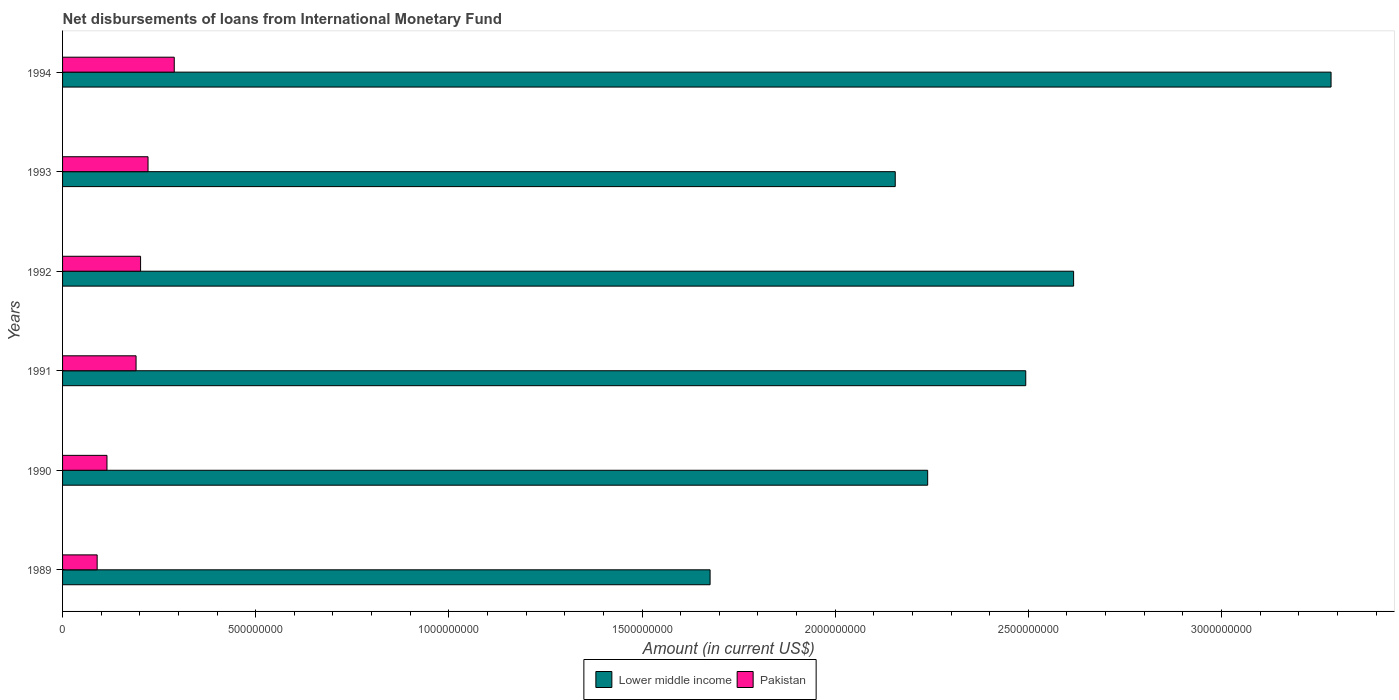What is the label of the 3rd group of bars from the top?
Your answer should be compact. 1992. In how many cases, is the number of bars for a given year not equal to the number of legend labels?
Offer a very short reply. 0. What is the amount of loans disbursed in Lower middle income in 1990?
Your answer should be very brief. 2.24e+09. Across all years, what is the maximum amount of loans disbursed in Lower middle income?
Provide a succinct answer. 3.28e+09. Across all years, what is the minimum amount of loans disbursed in Pakistan?
Offer a terse response. 8.95e+07. In which year was the amount of loans disbursed in Pakistan maximum?
Your answer should be very brief. 1994. In which year was the amount of loans disbursed in Pakistan minimum?
Your response must be concise. 1989. What is the total amount of loans disbursed in Pakistan in the graph?
Your response must be concise. 1.11e+09. What is the difference between the amount of loans disbursed in Pakistan in 1992 and that in 1993?
Keep it short and to the point. -1.93e+07. What is the difference between the amount of loans disbursed in Pakistan in 1990 and the amount of loans disbursed in Lower middle income in 1991?
Make the answer very short. -2.38e+09. What is the average amount of loans disbursed in Lower middle income per year?
Your response must be concise. 2.41e+09. In the year 1993, what is the difference between the amount of loans disbursed in Lower middle income and amount of loans disbursed in Pakistan?
Provide a succinct answer. 1.93e+09. In how many years, is the amount of loans disbursed in Pakistan greater than 2600000000 US$?
Provide a succinct answer. 0. What is the ratio of the amount of loans disbursed in Pakistan in 1990 to that in 1992?
Your answer should be very brief. 0.57. What is the difference between the highest and the second highest amount of loans disbursed in Pakistan?
Provide a succinct answer. 6.79e+07. What is the difference between the highest and the lowest amount of loans disbursed in Lower middle income?
Offer a very short reply. 1.61e+09. Is the sum of the amount of loans disbursed in Lower middle income in 1989 and 1994 greater than the maximum amount of loans disbursed in Pakistan across all years?
Ensure brevity in your answer.  Yes. What does the 2nd bar from the top in 1994 represents?
Ensure brevity in your answer.  Lower middle income. What does the 2nd bar from the bottom in 1993 represents?
Offer a terse response. Pakistan. How many bars are there?
Offer a terse response. 12. What is the difference between two consecutive major ticks on the X-axis?
Your answer should be very brief. 5.00e+08. Are the values on the major ticks of X-axis written in scientific E-notation?
Ensure brevity in your answer.  No. Does the graph contain grids?
Ensure brevity in your answer.  No. Where does the legend appear in the graph?
Your response must be concise. Bottom center. How many legend labels are there?
Make the answer very short. 2. How are the legend labels stacked?
Your answer should be very brief. Horizontal. What is the title of the graph?
Give a very brief answer. Net disbursements of loans from International Monetary Fund. What is the label or title of the X-axis?
Your answer should be very brief. Amount (in current US$). What is the label or title of the Y-axis?
Provide a short and direct response. Years. What is the Amount (in current US$) in Lower middle income in 1989?
Offer a very short reply. 1.68e+09. What is the Amount (in current US$) in Pakistan in 1989?
Make the answer very short. 8.95e+07. What is the Amount (in current US$) of Lower middle income in 1990?
Keep it short and to the point. 2.24e+09. What is the Amount (in current US$) in Pakistan in 1990?
Keep it short and to the point. 1.15e+08. What is the Amount (in current US$) in Lower middle income in 1991?
Offer a terse response. 2.49e+09. What is the Amount (in current US$) of Pakistan in 1991?
Provide a short and direct response. 1.90e+08. What is the Amount (in current US$) in Lower middle income in 1992?
Offer a terse response. 2.62e+09. What is the Amount (in current US$) of Pakistan in 1992?
Offer a very short reply. 2.02e+08. What is the Amount (in current US$) of Lower middle income in 1993?
Offer a very short reply. 2.16e+09. What is the Amount (in current US$) of Pakistan in 1993?
Offer a very short reply. 2.21e+08. What is the Amount (in current US$) of Lower middle income in 1994?
Give a very brief answer. 3.28e+09. What is the Amount (in current US$) in Pakistan in 1994?
Provide a succinct answer. 2.89e+08. Across all years, what is the maximum Amount (in current US$) of Lower middle income?
Make the answer very short. 3.28e+09. Across all years, what is the maximum Amount (in current US$) of Pakistan?
Make the answer very short. 2.89e+08. Across all years, what is the minimum Amount (in current US$) of Lower middle income?
Give a very brief answer. 1.68e+09. Across all years, what is the minimum Amount (in current US$) in Pakistan?
Keep it short and to the point. 8.95e+07. What is the total Amount (in current US$) of Lower middle income in the graph?
Keep it short and to the point. 1.45e+1. What is the total Amount (in current US$) in Pakistan in the graph?
Keep it short and to the point. 1.11e+09. What is the difference between the Amount (in current US$) of Lower middle income in 1989 and that in 1990?
Keep it short and to the point. -5.63e+08. What is the difference between the Amount (in current US$) in Pakistan in 1989 and that in 1990?
Your response must be concise. -2.54e+07. What is the difference between the Amount (in current US$) of Lower middle income in 1989 and that in 1991?
Provide a succinct answer. -8.17e+08. What is the difference between the Amount (in current US$) in Pakistan in 1989 and that in 1991?
Ensure brevity in your answer.  -1.01e+08. What is the difference between the Amount (in current US$) of Lower middle income in 1989 and that in 1992?
Make the answer very short. -9.41e+08. What is the difference between the Amount (in current US$) in Pakistan in 1989 and that in 1992?
Provide a short and direct response. -1.12e+08. What is the difference between the Amount (in current US$) of Lower middle income in 1989 and that in 1993?
Your answer should be compact. -4.79e+08. What is the difference between the Amount (in current US$) in Pakistan in 1989 and that in 1993?
Your answer should be very brief. -1.32e+08. What is the difference between the Amount (in current US$) of Lower middle income in 1989 and that in 1994?
Keep it short and to the point. -1.61e+09. What is the difference between the Amount (in current US$) of Pakistan in 1989 and that in 1994?
Give a very brief answer. -2.00e+08. What is the difference between the Amount (in current US$) in Lower middle income in 1990 and that in 1991?
Ensure brevity in your answer.  -2.54e+08. What is the difference between the Amount (in current US$) of Pakistan in 1990 and that in 1991?
Ensure brevity in your answer.  -7.53e+07. What is the difference between the Amount (in current US$) in Lower middle income in 1990 and that in 1992?
Your answer should be compact. -3.78e+08. What is the difference between the Amount (in current US$) of Pakistan in 1990 and that in 1992?
Your answer should be compact. -8.70e+07. What is the difference between the Amount (in current US$) in Lower middle income in 1990 and that in 1993?
Your answer should be compact. 8.39e+07. What is the difference between the Amount (in current US$) of Pakistan in 1990 and that in 1993?
Offer a very short reply. -1.06e+08. What is the difference between the Amount (in current US$) in Lower middle income in 1990 and that in 1994?
Provide a succinct answer. -1.04e+09. What is the difference between the Amount (in current US$) of Pakistan in 1990 and that in 1994?
Your response must be concise. -1.74e+08. What is the difference between the Amount (in current US$) in Lower middle income in 1991 and that in 1992?
Offer a terse response. -1.24e+08. What is the difference between the Amount (in current US$) in Pakistan in 1991 and that in 1992?
Offer a very short reply. -1.17e+07. What is the difference between the Amount (in current US$) in Lower middle income in 1991 and that in 1993?
Offer a terse response. 3.38e+08. What is the difference between the Amount (in current US$) in Pakistan in 1991 and that in 1993?
Offer a terse response. -3.10e+07. What is the difference between the Amount (in current US$) of Lower middle income in 1991 and that in 1994?
Your answer should be compact. -7.90e+08. What is the difference between the Amount (in current US$) in Pakistan in 1991 and that in 1994?
Keep it short and to the point. -9.89e+07. What is the difference between the Amount (in current US$) of Lower middle income in 1992 and that in 1993?
Keep it short and to the point. 4.62e+08. What is the difference between the Amount (in current US$) in Pakistan in 1992 and that in 1993?
Give a very brief answer. -1.93e+07. What is the difference between the Amount (in current US$) in Lower middle income in 1992 and that in 1994?
Provide a short and direct response. -6.66e+08. What is the difference between the Amount (in current US$) of Pakistan in 1992 and that in 1994?
Your answer should be very brief. -8.72e+07. What is the difference between the Amount (in current US$) of Lower middle income in 1993 and that in 1994?
Give a very brief answer. -1.13e+09. What is the difference between the Amount (in current US$) of Pakistan in 1993 and that in 1994?
Your response must be concise. -6.79e+07. What is the difference between the Amount (in current US$) in Lower middle income in 1989 and the Amount (in current US$) in Pakistan in 1990?
Your answer should be very brief. 1.56e+09. What is the difference between the Amount (in current US$) in Lower middle income in 1989 and the Amount (in current US$) in Pakistan in 1991?
Your answer should be very brief. 1.49e+09. What is the difference between the Amount (in current US$) in Lower middle income in 1989 and the Amount (in current US$) in Pakistan in 1992?
Provide a succinct answer. 1.47e+09. What is the difference between the Amount (in current US$) in Lower middle income in 1989 and the Amount (in current US$) in Pakistan in 1993?
Your response must be concise. 1.45e+09. What is the difference between the Amount (in current US$) in Lower middle income in 1989 and the Amount (in current US$) in Pakistan in 1994?
Keep it short and to the point. 1.39e+09. What is the difference between the Amount (in current US$) of Lower middle income in 1990 and the Amount (in current US$) of Pakistan in 1991?
Give a very brief answer. 2.05e+09. What is the difference between the Amount (in current US$) in Lower middle income in 1990 and the Amount (in current US$) in Pakistan in 1992?
Your response must be concise. 2.04e+09. What is the difference between the Amount (in current US$) in Lower middle income in 1990 and the Amount (in current US$) in Pakistan in 1993?
Provide a short and direct response. 2.02e+09. What is the difference between the Amount (in current US$) of Lower middle income in 1990 and the Amount (in current US$) of Pakistan in 1994?
Your answer should be very brief. 1.95e+09. What is the difference between the Amount (in current US$) of Lower middle income in 1991 and the Amount (in current US$) of Pakistan in 1992?
Give a very brief answer. 2.29e+09. What is the difference between the Amount (in current US$) in Lower middle income in 1991 and the Amount (in current US$) in Pakistan in 1993?
Provide a succinct answer. 2.27e+09. What is the difference between the Amount (in current US$) in Lower middle income in 1991 and the Amount (in current US$) in Pakistan in 1994?
Ensure brevity in your answer.  2.20e+09. What is the difference between the Amount (in current US$) in Lower middle income in 1992 and the Amount (in current US$) in Pakistan in 1993?
Provide a short and direct response. 2.40e+09. What is the difference between the Amount (in current US$) in Lower middle income in 1992 and the Amount (in current US$) in Pakistan in 1994?
Give a very brief answer. 2.33e+09. What is the difference between the Amount (in current US$) of Lower middle income in 1993 and the Amount (in current US$) of Pakistan in 1994?
Your answer should be compact. 1.87e+09. What is the average Amount (in current US$) in Lower middle income per year?
Keep it short and to the point. 2.41e+09. What is the average Amount (in current US$) of Pakistan per year?
Make the answer very short. 1.85e+08. In the year 1989, what is the difference between the Amount (in current US$) of Lower middle income and Amount (in current US$) of Pakistan?
Provide a short and direct response. 1.59e+09. In the year 1990, what is the difference between the Amount (in current US$) of Lower middle income and Amount (in current US$) of Pakistan?
Your answer should be very brief. 2.12e+09. In the year 1991, what is the difference between the Amount (in current US$) of Lower middle income and Amount (in current US$) of Pakistan?
Provide a succinct answer. 2.30e+09. In the year 1992, what is the difference between the Amount (in current US$) in Lower middle income and Amount (in current US$) in Pakistan?
Provide a short and direct response. 2.42e+09. In the year 1993, what is the difference between the Amount (in current US$) of Lower middle income and Amount (in current US$) of Pakistan?
Provide a succinct answer. 1.93e+09. In the year 1994, what is the difference between the Amount (in current US$) of Lower middle income and Amount (in current US$) of Pakistan?
Offer a very short reply. 2.99e+09. What is the ratio of the Amount (in current US$) of Lower middle income in 1989 to that in 1990?
Your response must be concise. 0.75. What is the ratio of the Amount (in current US$) of Pakistan in 1989 to that in 1990?
Provide a short and direct response. 0.78. What is the ratio of the Amount (in current US$) of Lower middle income in 1989 to that in 1991?
Your answer should be compact. 0.67. What is the ratio of the Amount (in current US$) in Pakistan in 1989 to that in 1991?
Offer a very short reply. 0.47. What is the ratio of the Amount (in current US$) of Lower middle income in 1989 to that in 1992?
Your answer should be very brief. 0.64. What is the ratio of the Amount (in current US$) of Pakistan in 1989 to that in 1992?
Your answer should be very brief. 0.44. What is the ratio of the Amount (in current US$) in Lower middle income in 1989 to that in 1993?
Keep it short and to the point. 0.78. What is the ratio of the Amount (in current US$) of Pakistan in 1989 to that in 1993?
Offer a terse response. 0.4. What is the ratio of the Amount (in current US$) of Lower middle income in 1989 to that in 1994?
Keep it short and to the point. 0.51. What is the ratio of the Amount (in current US$) in Pakistan in 1989 to that in 1994?
Offer a very short reply. 0.31. What is the ratio of the Amount (in current US$) in Lower middle income in 1990 to that in 1991?
Offer a terse response. 0.9. What is the ratio of the Amount (in current US$) of Pakistan in 1990 to that in 1991?
Keep it short and to the point. 0.6. What is the ratio of the Amount (in current US$) in Lower middle income in 1990 to that in 1992?
Provide a succinct answer. 0.86. What is the ratio of the Amount (in current US$) in Pakistan in 1990 to that in 1992?
Offer a very short reply. 0.57. What is the ratio of the Amount (in current US$) of Lower middle income in 1990 to that in 1993?
Ensure brevity in your answer.  1.04. What is the ratio of the Amount (in current US$) in Pakistan in 1990 to that in 1993?
Make the answer very short. 0.52. What is the ratio of the Amount (in current US$) in Lower middle income in 1990 to that in 1994?
Offer a terse response. 0.68. What is the ratio of the Amount (in current US$) of Pakistan in 1990 to that in 1994?
Provide a short and direct response. 0.4. What is the ratio of the Amount (in current US$) of Lower middle income in 1991 to that in 1992?
Give a very brief answer. 0.95. What is the ratio of the Amount (in current US$) of Pakistan in 1991 to that in 1992?
Make the answer very short. 0.94. What is the ratio of the Amount (in current US$) in Lower middle income in 1991 to that in 1993?
Provide a succinct answer. 1.16. What is the ratio of the Amount (in current US$) in Pakistan in 1991 to that in 1993?
Your response must be concise. 0.86. What is the ratio of the Amount (in current US$) in Lower middle income in 1991 to that in 1994?
Provide a short and direct response. 0.76. What is the ratio of the Amount (in current US$) in Pakistan in 1991 to that in 1994?
Offer a very short reply. 0.66. What is the ratio of the Amount (in current US$) of Lower middle income in 1992 to that in 1993?
Offer a very short reply. 1.21. What is the ratio of the Amount (in current US$) in Pakistan in 1992 to that in 1993?
Keep it short and to the point. 0.91. What is the ratio of the Amount (in current US$) of Lower middle income in 1992 to that in 1994?
Keep it short and to the point. 0.8. What is the ratio of the Amount (in current US$) in Pakistan in 1992 to that in 1994?
Keep it short and to the point. 0.7. What is the ratio of the Amount (in current US$) in Lower middle income in 1993 to that in 1994?
Your answer should be very brief. 0.66. What is the ratio of the Amount (in current US$) of Pakistan in 1993 to that in 1994?
Make the answer very short. 0.77. What is the difference between the highest and the second highest Amount (in current US$) of Lower middle income?
Offer a very short reply. 6.66e+08. What is the difference between the highest and the second highest Amount (in current US$) of Pakistan?
Make the answer very short. 6.79e+07. What is the difference between the highest and the lowest Amount (in current US$) of Lower middle income?
Provide a succinct answer. 1.61e+09. What is the difference between the highest and the lowest Amount (in current US$) of Pakistan?
Your answer should be compact. 2.00e+08. 